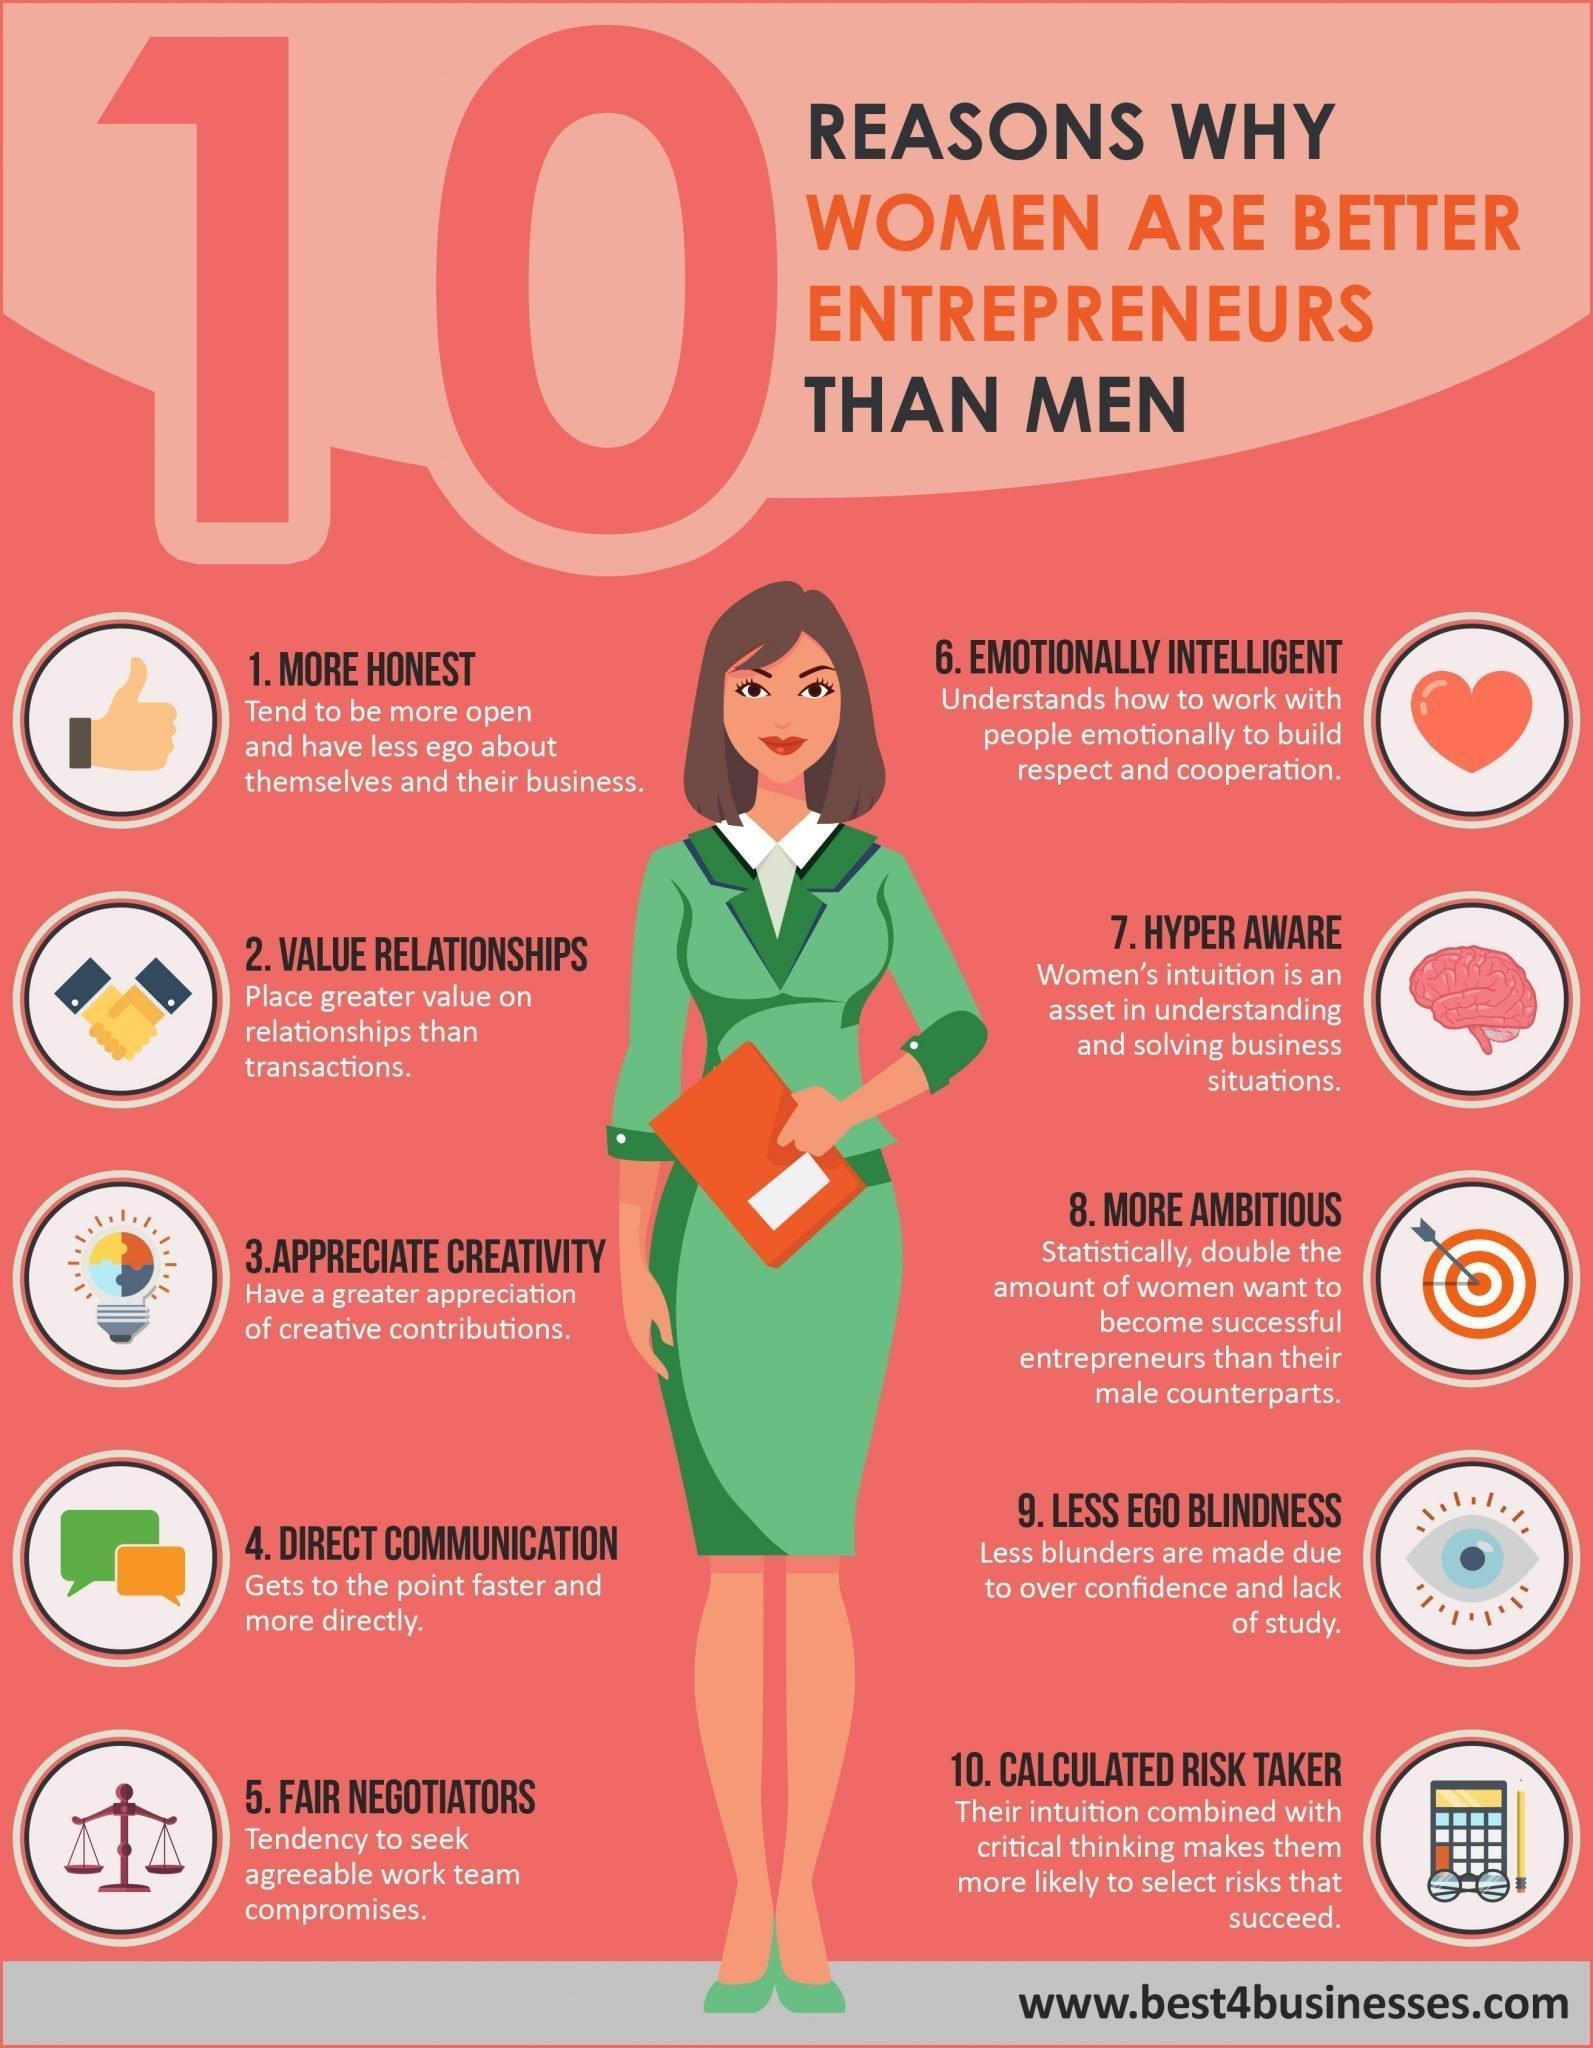what characteristic of women does the calculator\ indicate
Answer the question with a short phrase. calculated risk taker what characteristic of women does the weighing scale indicate fair negotiations who are more honest, men or women women what characteristic of women does the dart board indicate more ambitious 